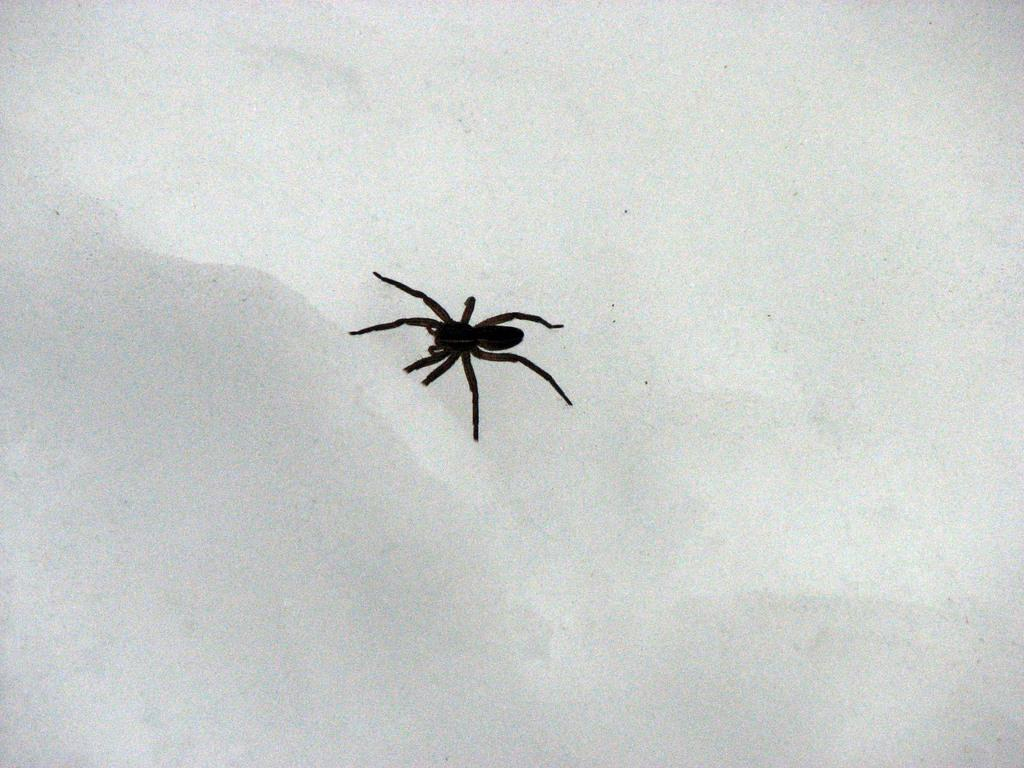What is the main subject of the image? The main subject of the image is a spider. Can you describe the spider's location in the image? The spider is on a plane surface in the image. What type of pancake is being served to the cattle in the image? There is no pancake or cattle present in the image; it features a spider on a plane surface. 